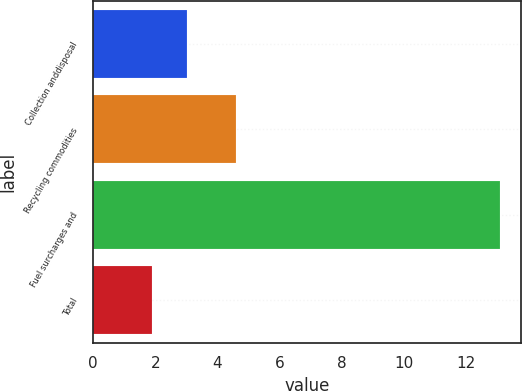Convert chart. <chart><loc_0><loc_0><loc_500><loc_500><bar_chart><fcel>Collection anddisposal<fcel>Recycling commodities<fcel>Fuel surcharges and<fcel>Total<nl><fcel>3.02<fcel>4.6<fcel>13.1<fcel>1.9<nl></chart> 